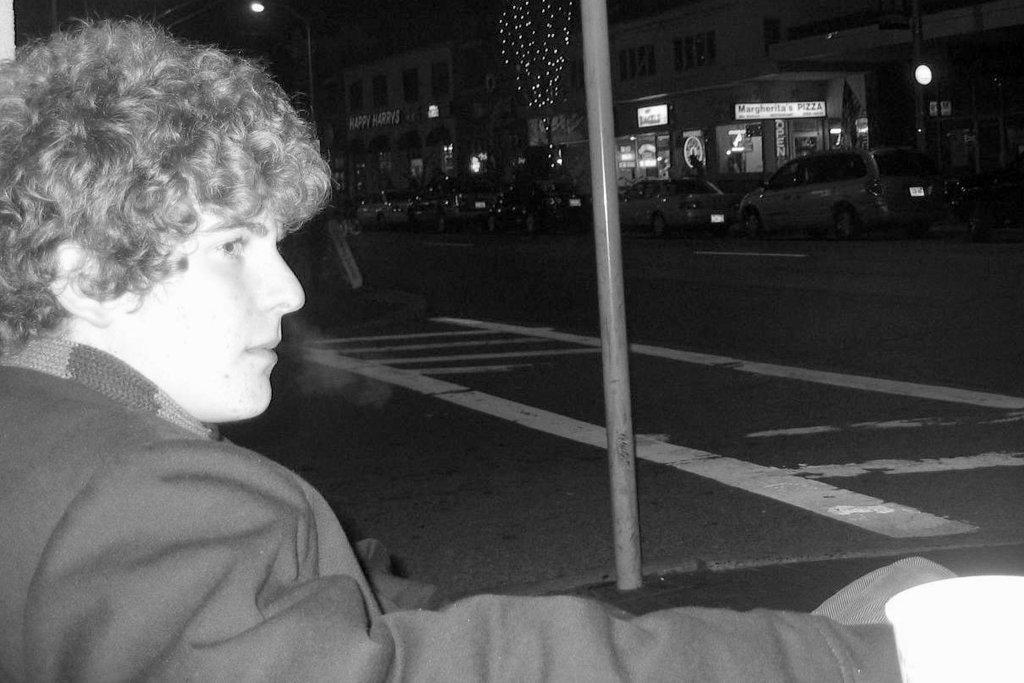How would you summarize this image in a sentence or two? In this image on the left side there is one person, and in the background there are poles, buildings, trees, vehicles and some lights and some objects. At the bottom there is road. 